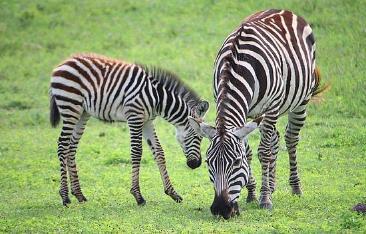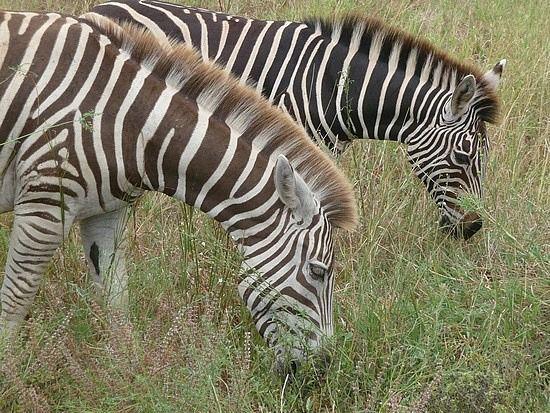The first image is the image on the left, the second image is the image on the right. Analyze the images presented: Is the assertion "A baby zebra is shown nursing in one image." valid? Answer yes or no. No. The first image is the image on the left, the second image is the image on the right. Examine the images to the left and right. Is the description "There is a baby zebra eating from its mother zebra." accurate? Answer yes or no. No. 